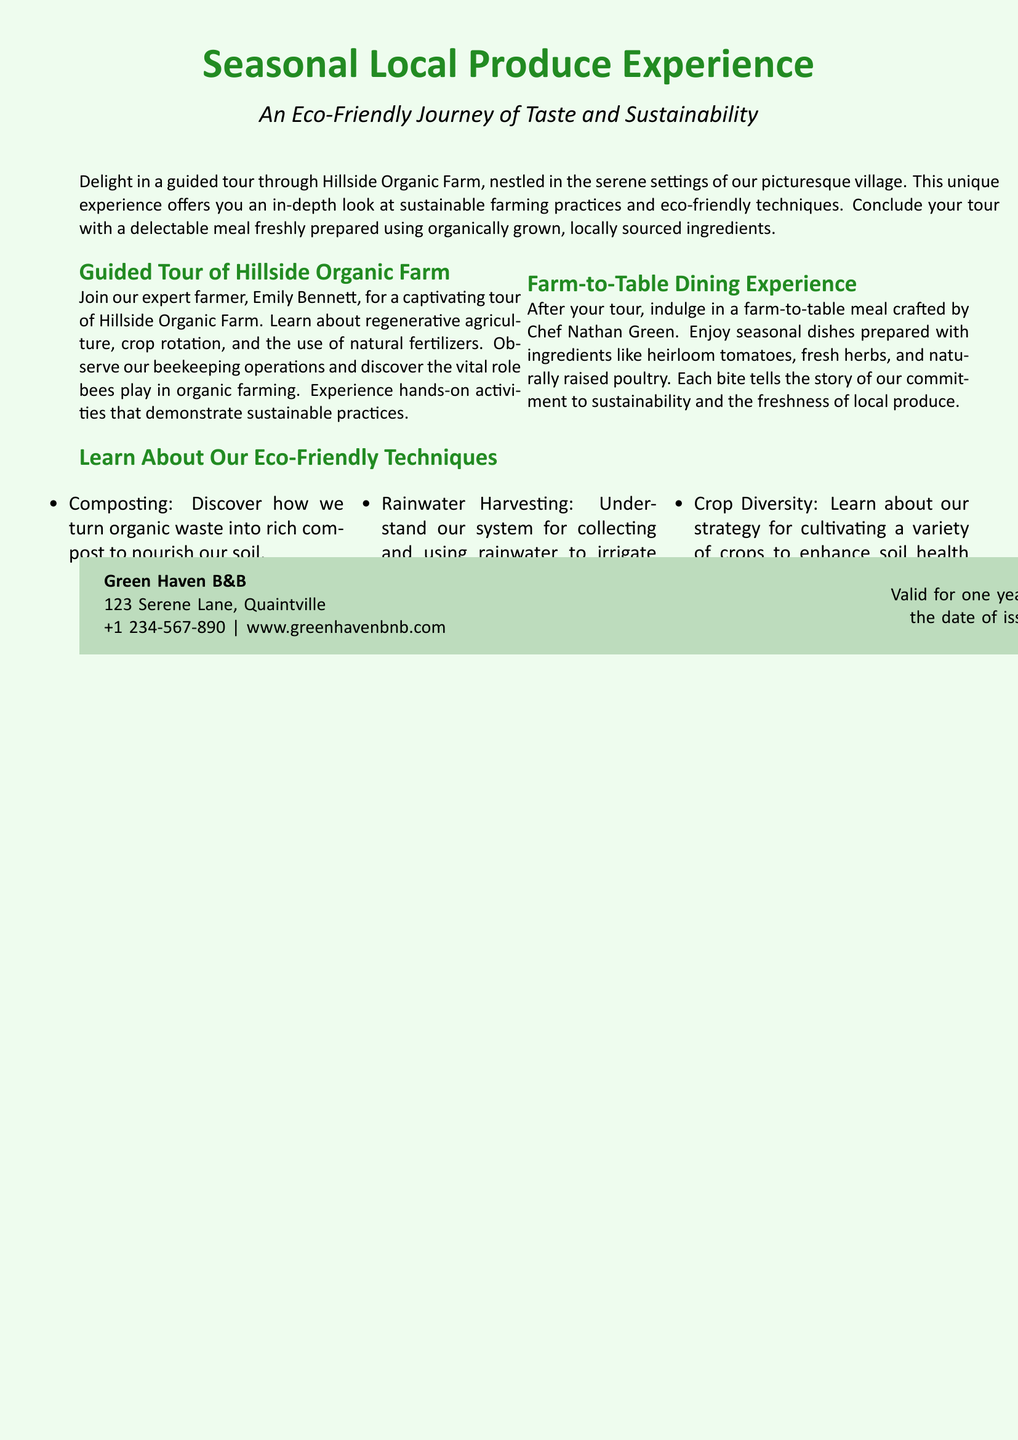What is the name of the farm? The farm featured in the experience is called Hillside Organic Farm.
Answer: Hillside Organic Farm Who is the expert farmer leading the tour? The guided tour is led by Emily Bennett, the expert farmer.
Answer: Emily Bennett What type of farming practices will be observed during the tour? The tour includes sustainable farming practices such as regenerative agriculture and crop rotation.
Answer: Sustainable farming practices Who prepares the meal after the tour? The meal after the tour is crafted by Chef Nathan Green.
Answer: Chef Nathan Green What is one eco-friendly technique mentioned in the document? One eco-friendly technique mentioned is composting.
Answer: Composting How long is the voucher valid for? The voucher is valid for one year from the date of issuance.
Answer: One year What is the primary focus of the meal served? The meal served focuses on using locally sourced ingredients.
Answer: Locally sourced ingredients What is the contact number for Green Haven B&B? The contact number listed for Green Haven B&B is +1 234-567-890.
Answer: +1 234-567-890 What kind of dining experience is included in the voucher? The voucher includes a farm-to-table dining experience.
Answer: Farm-to-table dining experience How many eco-friendly techniques are listed in the document? Three eco-friendly techniques are listed in the document.
Answer: Three 